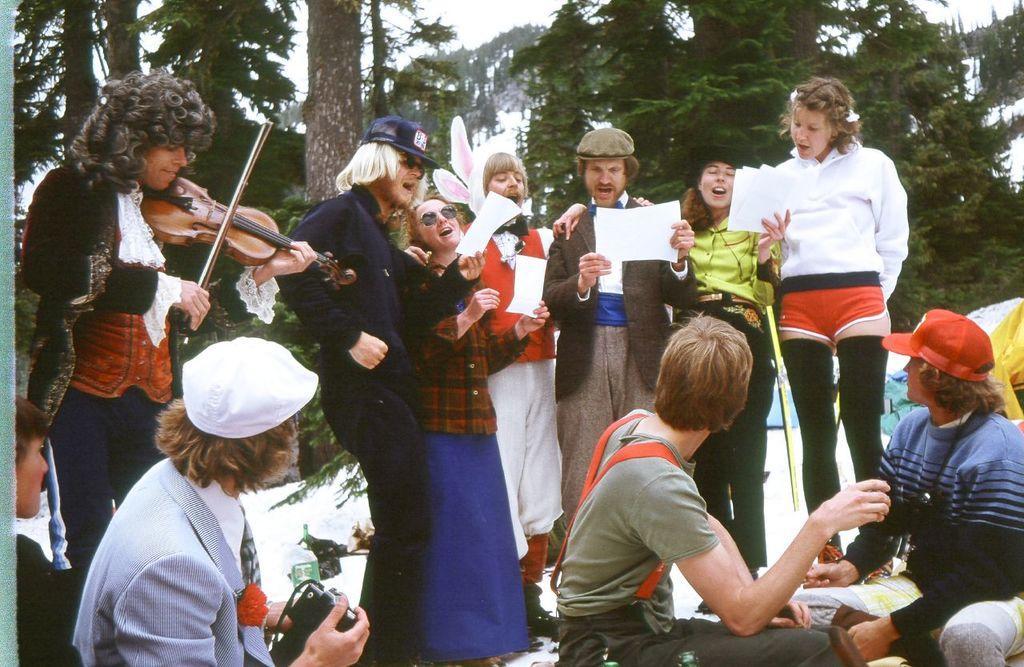Please provide a concise description of this image. There are so many people standing under a tree some holding a paper and some a musical instrument and some people sitting in front of them holding a camera in which few of them are singing and few of them are playing music. 